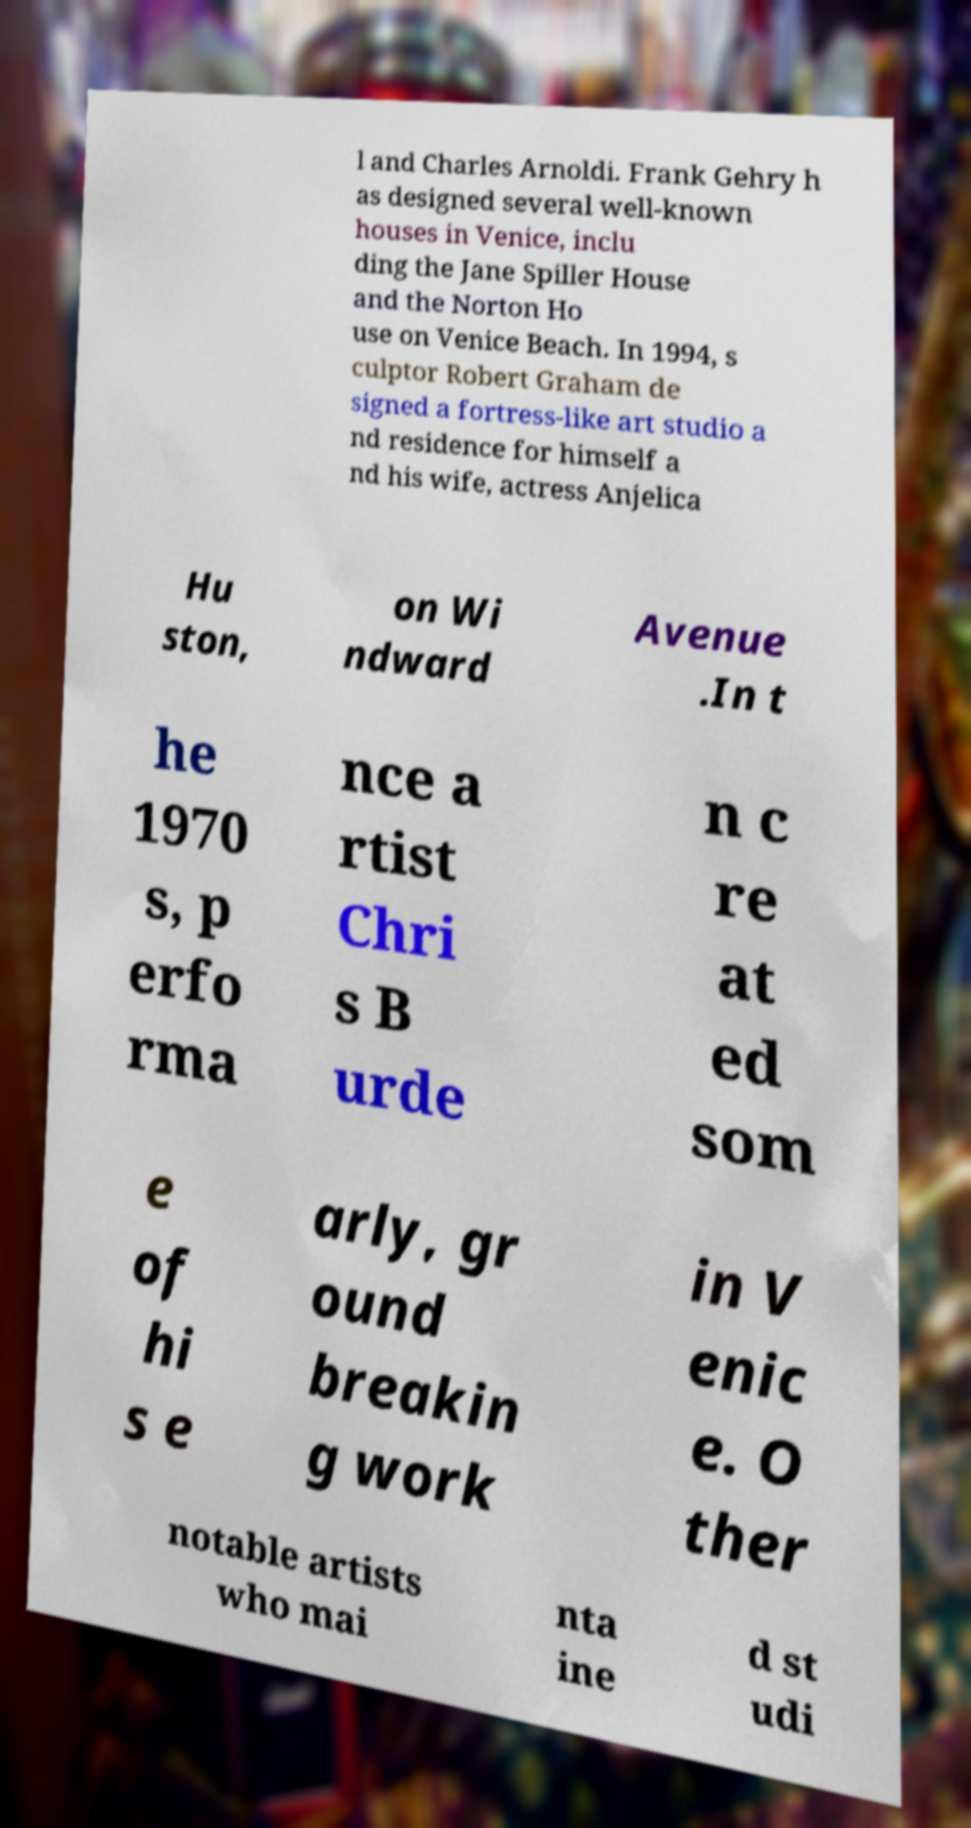Could you assist in decoding the text presented in this image and type it out clearly? l and Charles Arnoldi. Frank Gehry h as designed several well-known houses in Venice, inclu ding the Jane Spiller House and the Norton Ho use on Venice Beach. In 1994, s culptor Robert Graham de signed a fortress-like art studio a nd residence for himself a nd his wife, actress Anjelica Hu ston, on Wi ndward Avenue .In t he 1970 s, p erfo rma nce a rtist Chri s B urde n c re at ed som e of hi s e arly, gr ound breakin g work in V enic e. O ther notable artists who mai nta ine d st udi 